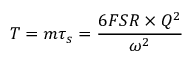<formula> <loc_0><loc_0><loc_500><loc_500>T = m \tau _ { s } = \frac { 6 F S R \times Q ^ { 2 } } { \omega ^ { 2 } }</formula> 